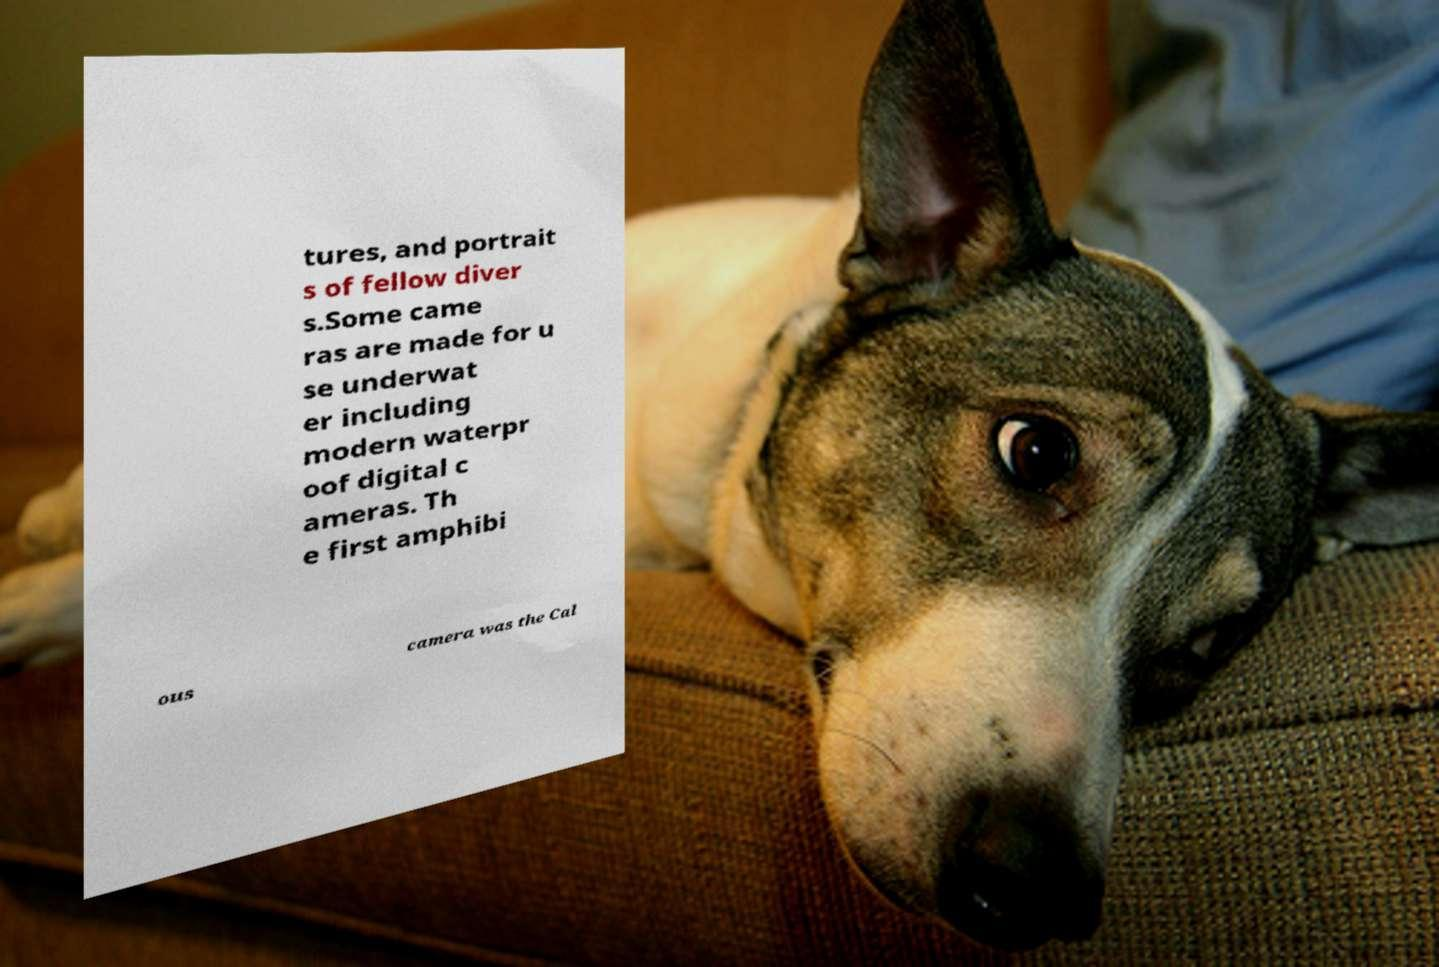There's text embedded in this image that I need extracted. Can you transcribe it verbatim? tures, and portrait s of fellow diver s.Some came ras are made for u se underwat er including modern waterpr oof digital c ameras. Th e first amphibi ous camera was the Cal 